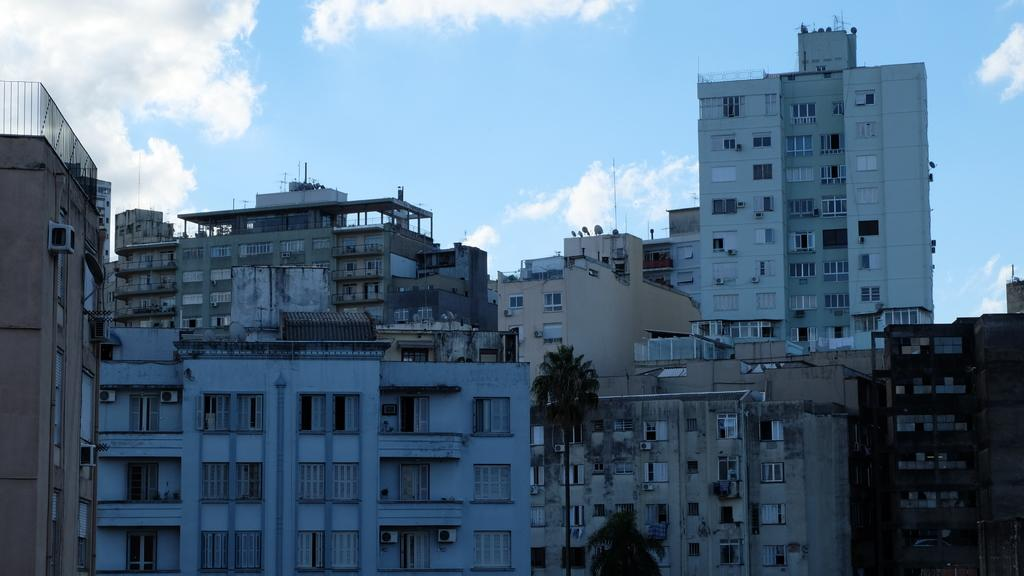What type of structures can be seen in the image? There are buildings in the image. What other natural elements are present in the image? There are trees in the image. What part of the natural environment is visible in the image? The sky is visible in the image. How many visitors are present in the image? There is no indication of visitors in the image; it only shows buildings, trees, and the sky. What type of legal advice is being given in the image? There is no lawyer or legal advice present in the image. 